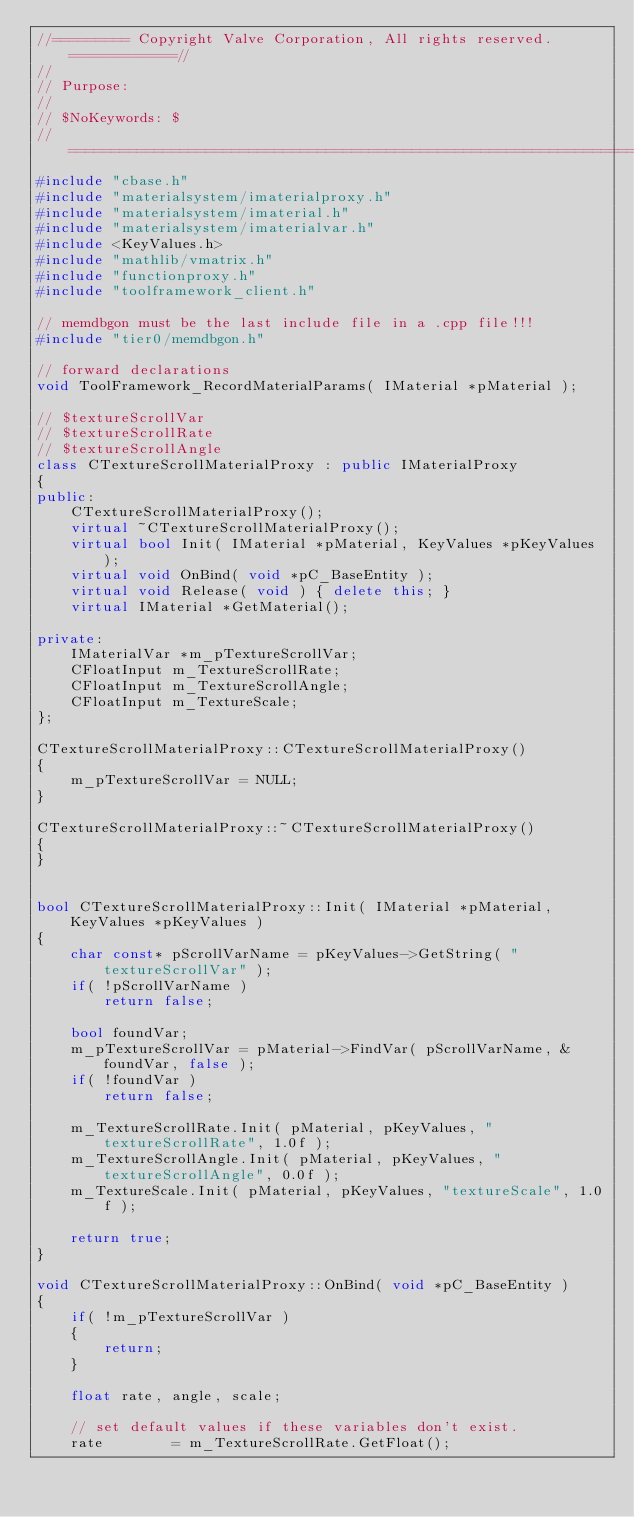Convert code to text. <code><loc_0><loc_0><loc_500><loc_500><_C++_>//========= Copyright Valve Corporation, All rights reserved. ============//
//
// Purpose:
//
// $NoKeywords: $
//=============================================================================//
#include "cbase.h"
#include "materialsystem/imaterialproxy.h"
#include "materialsystem/imaterial.h"
#include "materialsystem/imaterialvar.h"
#include <KeyValues.h>
#include "mathlib/vmatrix.h"
#include "functionproxy.h"
#include "toolframework_client.h"

// memdbgon must be the last include file in a .cpp file!!!
#include "tier0/memdbgon.h"

// forward declarations
void ToolFramework_RecordMaterialParams( IMaterial *pMaterial );

// $textureScrollVar
// $textureScrollRate
// $textureScrollAngle
class CTextureScrollMaterialProxy : public IMaterialProxy
{
public:
    CTextureScrollMaterialProxy();
    virtual ~CTextureScrollMaterialProxy();
    virtual bool Init( IMaterial *pMaterial, KeyValues *pKeyValues );
    virtual void OnBind( void *pC_BaseEntity );
    virtual void Release( void ) { delete this; }
    virtual IMaterial *GetMaterial();

private:
    IMaterialVar *m_pTextureScrollVar;
    CFloatInput m_TextureScrollRate;
    CFloatInput m_TextureScrollAngle;
    CFloatInput m_TextureScale;
};

CTextureScrollMaterialProxy::CTextureScrollMaterialProxy()
{
    m_pTextureScrollVar = NULL;
}

CTextureScrollMaterialProxy::~CTextureScrollMaterialProxy()
{
}


bool CTextureScrollMaterialProxy::Init( IMaterial *pMaterial, KeyValues *pKeyValues )
{
    char const* pScrollVarName = pKeyValues->GetString( "textureScrollVar" );
    if( !pScrollVarName )
        return false;

    bool foundVar;
    m_pTextureScrollVar = pMaterial->FindVar( pScrollVarName, &foundVar, false );
    if( !foundVar )
        return false;

    m_TextureScrollRate.Init( pMaterial, pKeyValues, "textureScrollRate", 1.0f );
    m_TextureScrollAngle.Init( pMaterial, pKeyValues, "textureScrollAngle", 0.0f );
    m_TextureScale.Init( pMaterial, pKeyValues, "textureScale", 1.0f );

    return true;
}

void CTextureScrollMaterialProxy::OnBind( void *pC_BaseEntity )
{
    if( !m_pTextureScrollVar )
    {
        return;
    }

    float rate, angle, scale;

    // set default values if these variables don't exist.
    rate        = m_TextureScrollRate.GetFloat();</code> 